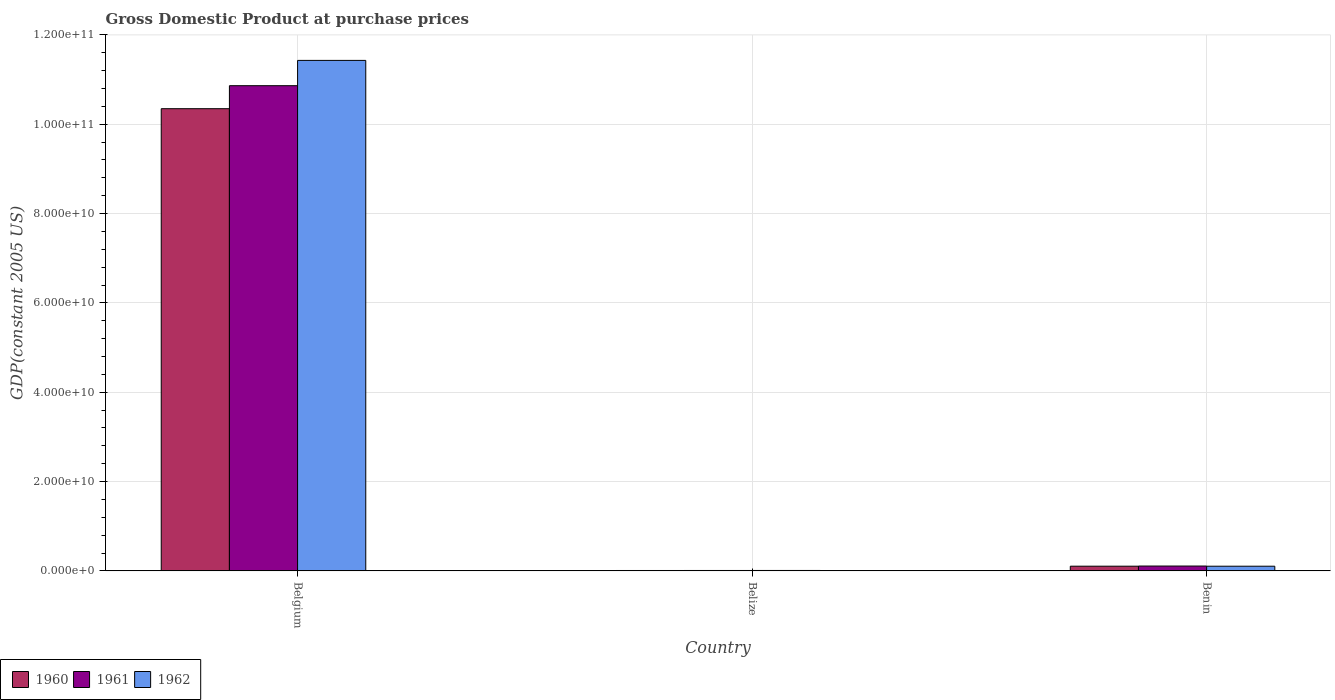How many groups of bars are there?
Keep it short and to the point. 3. How many bars are there on the 1st tick from the right?
Provide a short and direct response. 3. What is the label of the 1st group of bars from the left?
Your answer should be compact. Belgium. In how many cases, is the number of bars for a given country not equal to the number of legend labels?
Offer a terse response. 0. What is the GDP at purchase prices in 1960 in Belize?
Ensure brevity in your answer.  8.94e+07. Across all countries, what is the maximum GDP at purchase prices in 1960?
Your response must be concise. 1.03e+11. Across all countries, what is the minimum GDP at purchase prices in 1962?
Ensure brevity in your answer.  9.84e+07. In which country was the GDP at purchase prices in 1962 maximum?
Give a very brief answer. Belgium. In which country was the GDP at purchase prices in 1960 minimum?
Offer a terse response. Belize. What is the total GDP at purchase prices in 1961 in the graph?
Provide a succinct answer. 1.10e+11. What is the difference between the GDP at purchase prices in 1962 in Belgium and that in Benin?
Give a very brief answer. 1.13e+11. What is the difference between the GDP at purchase prices in 1961 in Belize and the GDP at purchase prices in 1962 in Benin?
Keep it short and to the point. -9.55e+08. What is the average GDP at purchase prices in 1962 per country?
Your response must be concise. 3.85e+1. What is the difference between the GDP at purchase prices of/in 1962 and GDP at purchase prices of/in 1960 in Benin?
Give a very brief answer. -4.14e+06. What is the ratio of the GDP at purchase prices in 1960 in Belgium to that in Benin?
Make the answer very short. 98.27. Is the GDP at purchase prices in 1961 in Belize less than that in Benin?
Offer a terse response. Yes. Is the difference between the GDP at purchase prices in 1962 in Belgium and Belize greater than the difference between the GDP at purchase prices in 1960 in Belgium and Belize?
Ensure brevity in your answer.  Yes. What is the difference between the highest and the second highest GDP at purchase prices in 1961?
Your answer should be compact. 1.08e+11. What is the difference between the highest and the lowest GDP at purchase prices in 1960?
Provide a short and direct response. 1.03e+11. In how many countries, is the GDP at purchase prices in 1961 greater than the average GDP at purchase prices in 1961 taken over all countries?
Provide a succinct answer. 1. How many bars are there?
Provide a succinct answer. 9. Are all the bars in the graph horizontal?
Provide a short and direct response. No. Does the graph contain any zero values?
Provide a short and direct response. No. How many legend labels are there?
Give a very brief answer. 3. What is the title of the graph?
Offer a very short reply. Gross Domestic Product at purchase prices. Does "1984" appear as one of the legend labels in the graph?
Your answer should be compact. No. What is the label or title of the Y-axis?
Ensure brevity in your answer.  GDP(constant 2005 US). What is the GDP(constant 2005 US) of 1960 in Belgium?
Your answer should be very brief. 1.03e+11. What is the GDP(constant 2005 US) in 1961 in Belgium?
Provide a short and direct response. 1.09e+11. What is the GDP(constant 2005 US) in 1962 in Belgium?
Give a very brief answer. 1.14e+11. What is the GDP(constant 2005 US) of 1960 in Belize?
Your response must be concise. 8.94e+07. What is the GDP(constant 2005 US) of 1961 in Belize?
Your response must be concise. 9.38e+07. What is the GDP(constant 2005 US) of 1962 in Belize?
Make the answer very short. 9.84e+07. What is the GDP(constant 2005 US) of 1960 in Benin?
Provide a short and direct response. 1.05e+09. What is the GDP(constant 2005 US) in 1961 in Benin?
Provide a succinct answer. 1.09e+09. What is the GDP(constant 2005 US) in 1962 in Benin?
Keep it short and to the point. 1.05e+09. Across all countries, what is the maximum GDP(constant 2005 US) in 1960?
Your answer should be very brief. 1.03e+11. Across all countries, what is the maximum GDP(constant 2005 US) of 1961?
Provide a succinct answer. 1.09e+11. Across all countries, what is the maximum GDP(constant 2005 US) in 1962?
Give a very brief answer. 1.14e+11. Across all countries, what is the minimum GDP(constant 2005 US) of 1960?
Offer a very short reply. 8.94e+07. Across all countries, what is the minimum GDP(constant 2005 US) of 1961?
Offer a very short reply. 9.38e+07. Across all countries, what is the minimum GDP(constant 2005 US) of 1962?
Make the answer very short. 9.84e+07. What is the total GDP(constant 2005 US) in 1960 in the graph?
Provide a short and direct response. 1.05e+11. What is the total GDP(constant 2005 US) of 1961 in the graph?
Make the answer very short. 1.10e+11. What is the total GDP(constant 2005 US) of 1962 in the graph?
Offer a terse response. 1.15e+11. What is the difference between the GDP(constant 2005 US) of 1960 in Belgium and that in Belize?
Give a very brief answer. 1.03e+11. What is the difference between the GDP(constant 2005 US) in 1961 in Belgium and that in Belize?
Give a very brief answer. 1.09e+11. What is the difference between the GDP(constant 2005 US) of 1962 in Belgium and that in Belize?
Your answer should be compact. 1.14e+11. What is the difference between the GDP(constant 2005 US) in 1960 in Belgium and that in Benin?
Your answer should be very brief. 1.02e+11. What is the difference between the GDP(constant 2005 US) of 1961 in Belgium and that in Benin?
Keep it short and to the point. 1.08e+11. What is the difference between the GDP(constant 2005 US) in 1962 in Belgium and that in Benin?
Make the answer very short. 1.13e+11. What is the difference between the GDP(constant 2005 US) of 1960 in Belize and that in Benin?
Make the answer very short. -9.64e+08. What is the difference between the GDP(constant 2005 US) in 1961 in Belize and that in Benin?
Offer a very short reply. -9.92e+08. What is the difference between the GDP(constant 2005 US) in 1962 in Belize and that in Benin?
Give a very brief answer. -9.50e+08. What is the difference between the GDP(constant 2005 US) in 1960 in Belgium and the GDP(constant 2005 US) in 1961 in Belize?
Keep it short and to the point. 1.03e+11. What is the difference between the GDP(constant 2005 US) in 1960 in Belgium and the GDP(constant 2005 US) in 1962 in Belize?
Provide a short and direct response. 1.03e+11. What is the difference between the GDP(constant 2005 US) of 1961 in Belgium and the GDP(constant 2005 US) of 1962 in Belize?
Provide a short and direct response. 1.09e+11. What is the difference between the GDP(constant 2005 US) of 1960 in Belgium and the GDP(constant 2005 US) of 1961 in Benin?
Provide a short and direct response. 1.02e+11. What is the difference between the GDP(constant 2005 US) in 1960 in Belgium and the GDP(constant 2005 US) in 1962 in Benin?
Ensure brevity in your answer.  1.02e+11. What is the difference between the GDP(constant 2005 US) in 1961 in Belgium and the GDP(constant 2005 US) in 1962 in Benin?
Offer a terse response. 1.08e+11. What is the difference between the GDP(constant 2005 US) in 1960 in Belize and the GDP(constant 2005 US) in 1961 in Benin?
Your answer should be very brief. -9.97e+08. What is the difference between the GDP(constant 2005 US) of 1960 in Belize and the GDP(constant 2005 US) of 1962 in Benin?
Provide a short and direct response. -9.59e+08. What is the difference between the GDP(constant 2005 US) of 1961 in Belize and the GDP(constant 2005 US) of 1962 in Benin?
Give a very brief answer. -9.55e+08. What is the average GDP(constant 2005 US) in 1960 per country?
Your response must be concise. 3.49e+1. What is the average GDP(constant 2005 US) of 1961 per country?
Keep it short and to the point. 3.66e+1. What is the average GDP(constant 2005 US) of 1962 per country?
Offer a very short reply. 3.85e+1. What is the difference between the GDP(constant 2005 US) in 1960 and GDP(constant 2005 US) in 1961 in Belgium?
Your response must be concise. -5.15e+09. What is the difference between the GDP(constant 2005 US) in 1960 and GDP(constant 2005 US) in 1962 in Belgium?
Ensure brevity in your answer.  -1.08e+1. What is the difference between the GDP(constant 2005 US) of 1961 and GDP(constant 2005 US) of 1962 in Belgium?
Give a very brief answer. -5.66e+09. What is the difference between the GDP(constant 2005 US) of 1960 and GDP(constant 2005 US) of 1961 in Belize?
Offer a very short reply. -4.38e+06. What is the difference between the GDP(constant 2005 US) in 1960 and GDP(constant 2005 US) in 1962 in Belize?
Your answer should be compact. -8.97e+06. What is the difference between the GDP(constant 2005 US) of 1961 and GDP(constant 2005 US) of 1962 in Belize?
Ensure brevity in your answer.  -4.59e+06. What is the difference between the GDP(constant 2005 US) in 1960 and GDP(constant 2005 US) in 1961 in Benin?
Make the answer very short. -3.31e+07. What is the difference between the GDP(constant 2005 US) in 1960 and GDP(constant 2005 US) in 1962 in Benin?
Offer a terse response. 4.14e+06. What is the difference between the GDP(constant 2005 US) of 1961 and GDP(constant 2005 US) of 1962 in Benin?
Provide a succinct answer. 3.72e+07. What is the ratio of the GDP(constant 2005 US) of 1960 in Belgium to that in Belize?
Keep it short and to the point. 1156.97. What is the ratio of the GDP(constant 2005 US) in 1961 in Belgium to that in Belize?
Provide a short and direct response. 1157.92. What is the ratio of the GDP(constant 2005 US) of 1962 in Belgium to that in Belize?
Keep it short and to the point. 1161.44. What is the ratio of the GDP(constant 2005 US) in 1960 in Belgium to that in Benin?
Offer a very short reply. 98.27. What is the ratio of the GDP(constant 2005 US) of 1961 in Belgium to that in Benin?
Provide a succinct answer. 100.02. What is the ratio of the GDP(constant 2005 US) in 1962 in Belgium to that in Benin?
Offer a very short reply. 108.97. What is the ratio of the GDP(constant 2005 US) in 1960 in Belize to that in Benin?
Ensure brevity in your answer.  0.08. What is the ratio of the GDP(constant 2005 US) of 1961 in Belize to that in Benin?
Your answer should be compact. 0.09. What is the ratio of the GDP(constant 2005 US) in 1962 in Belize to that in Benin?
Provide a succinct answer. 0.09. What is the difference between the highest and the second highest GDP(constant 2005 US) in 1960?
Give a very brief answer. 1.02e+11. What is the difference between the highest and the second highest GDP(constant 2005 US) in 1961?
Provide a short and direct response. 1.08e+11. What is the difference between the highest and the second highest GDP(constant 2005 US) in 1962?
Your response must be concise. 1.13e+11. What is the difference between the highest and the lowest GDP(constant 2005 US) of 1960?
Provide a succinct answer. 1.03e+11. What is the difference between the highest and the lowest GDP(constant 2005 US) of 1961?
Your answer should be very brief. 1.09e+11. What is the difference between the highest and the lowest GDP(constant 2005 US) in 1962?
Your answer should be very brief. 1.14e+11. 